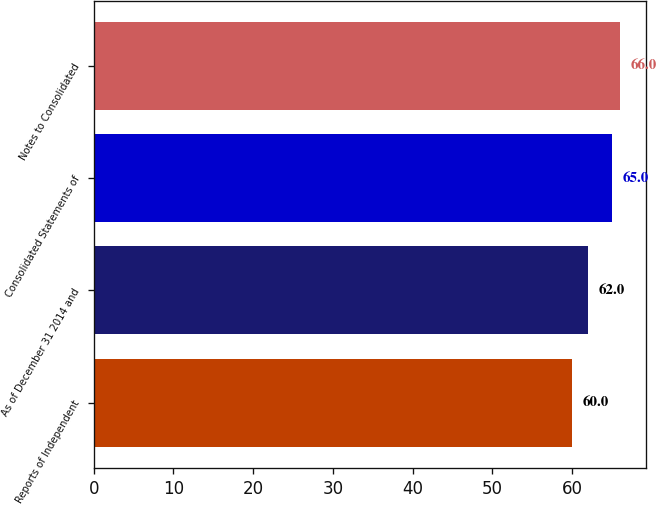Convert chart. <chart><loc_0><loc_0><loc_500><loc_500><bar_chart><fcel>Reports of Independent<fcel>As of December 31 2014 and<fcel>Consolidated Statements of<fcel>Notes to Consolidated<nl><fcel>60<fcel>62<fcel>65<fcel>66<nl></chart> 